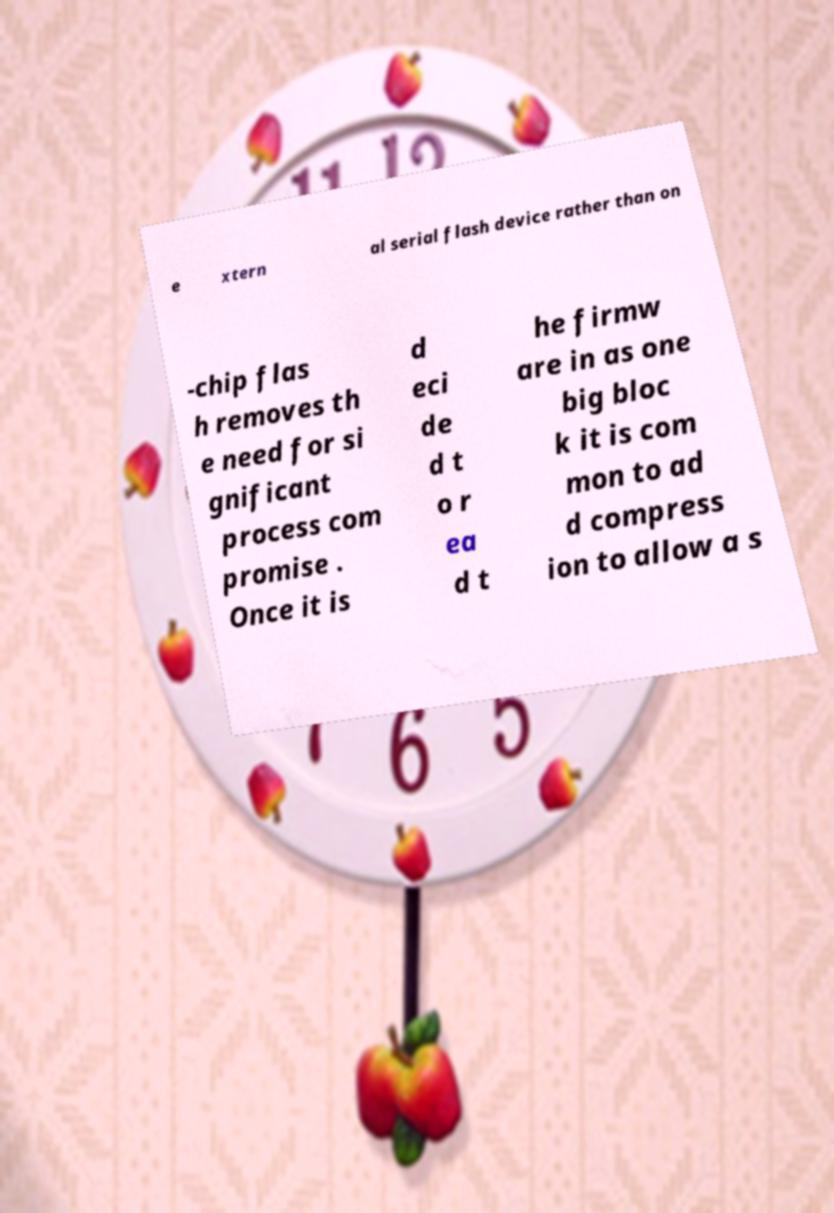Please identify and transcribe the text found in this image. e xtern al serial flash device rather than on -chip flas h removes th e need for si gnificant process com promise . Once it is d eci de d t o r ea d t he firmw are in as one big bloc k it is com mon to ad d compress ion to allow a s 